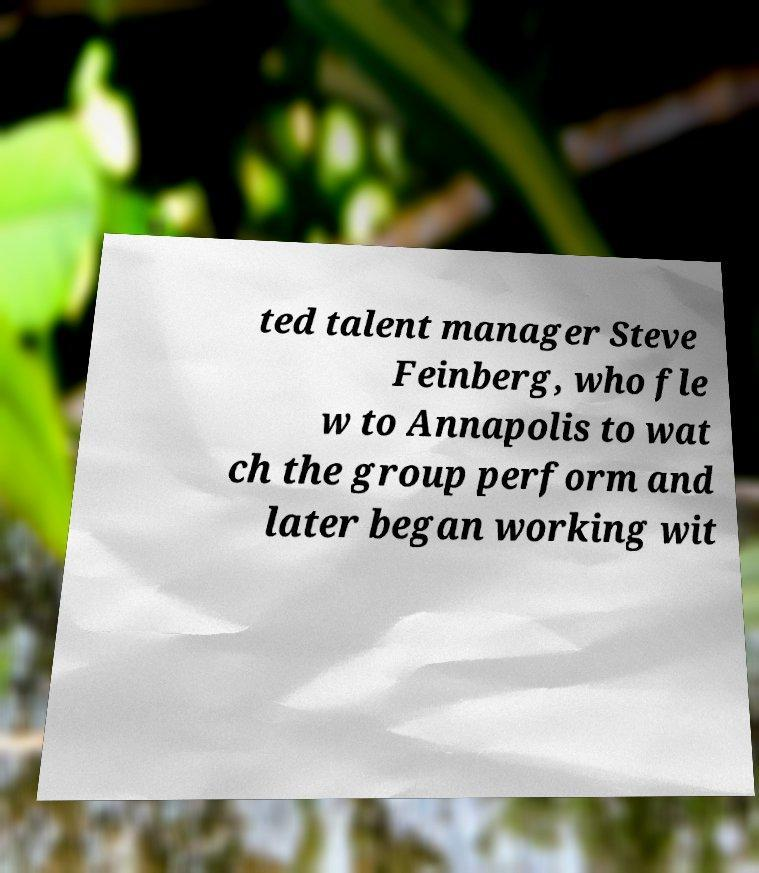For documentation purposes, I need the text within this image transcribed. Could you provide that? ted talent manager Steve Feinberg, who fle w to Annapolis to wat ch the group perform and later began working wit 